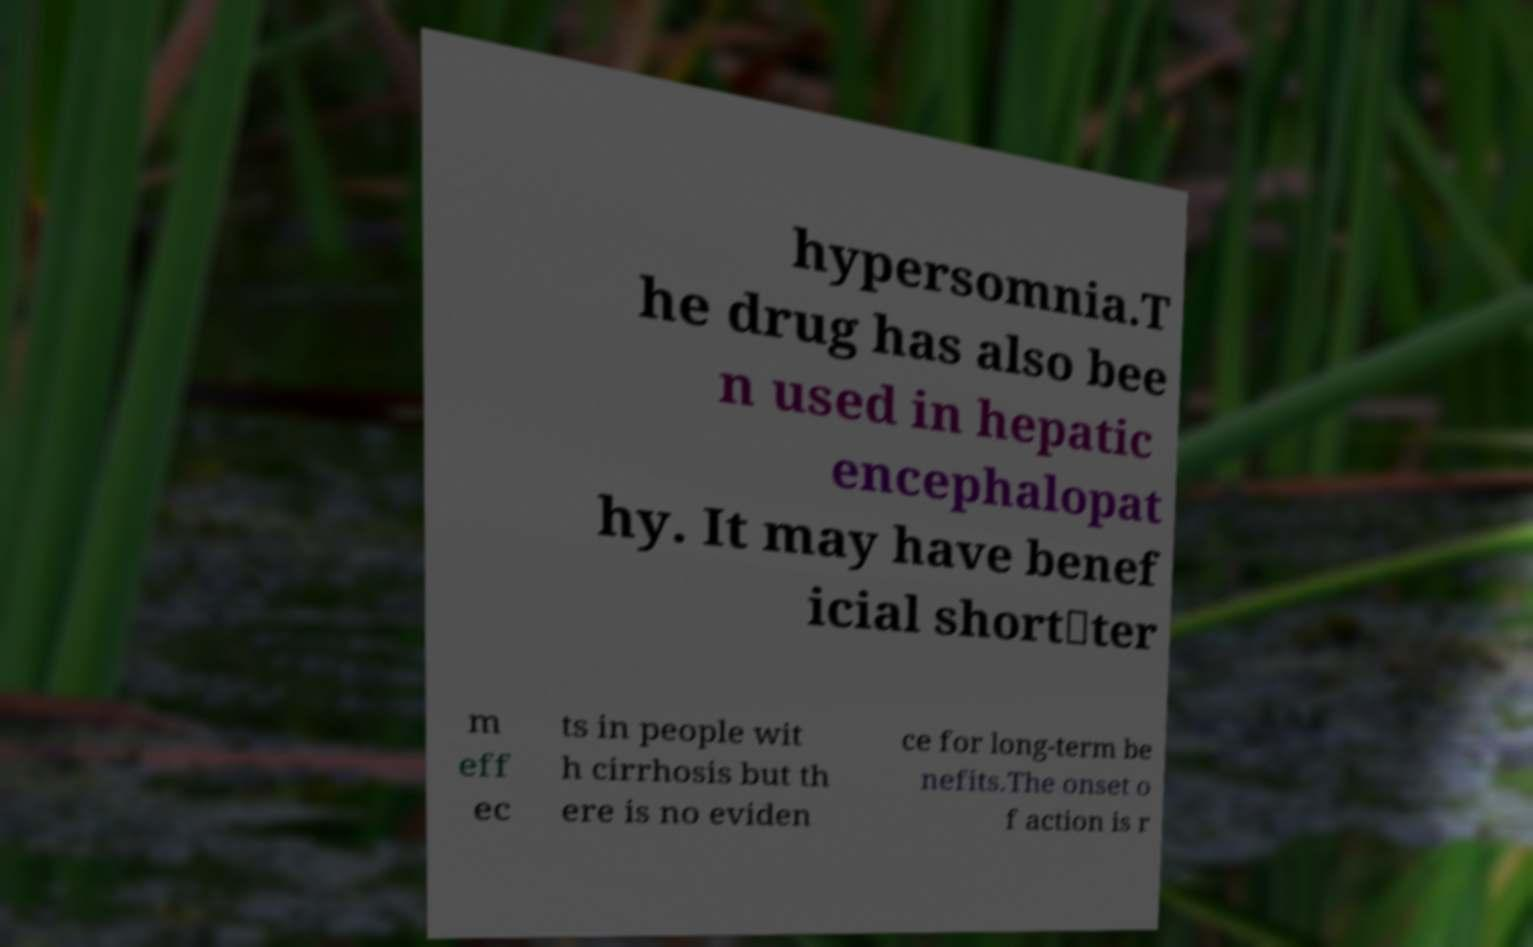Can you accurately transcribe the text from the provided image for me? hypersomnia.T he drug has also bee n used in hepatic encephalopat hy. It may have benef icial short‐ter m eff ec ts in people wit h cirrhosis but th ere is no eviden ce for long-term be nefits.The onset o f action is r 